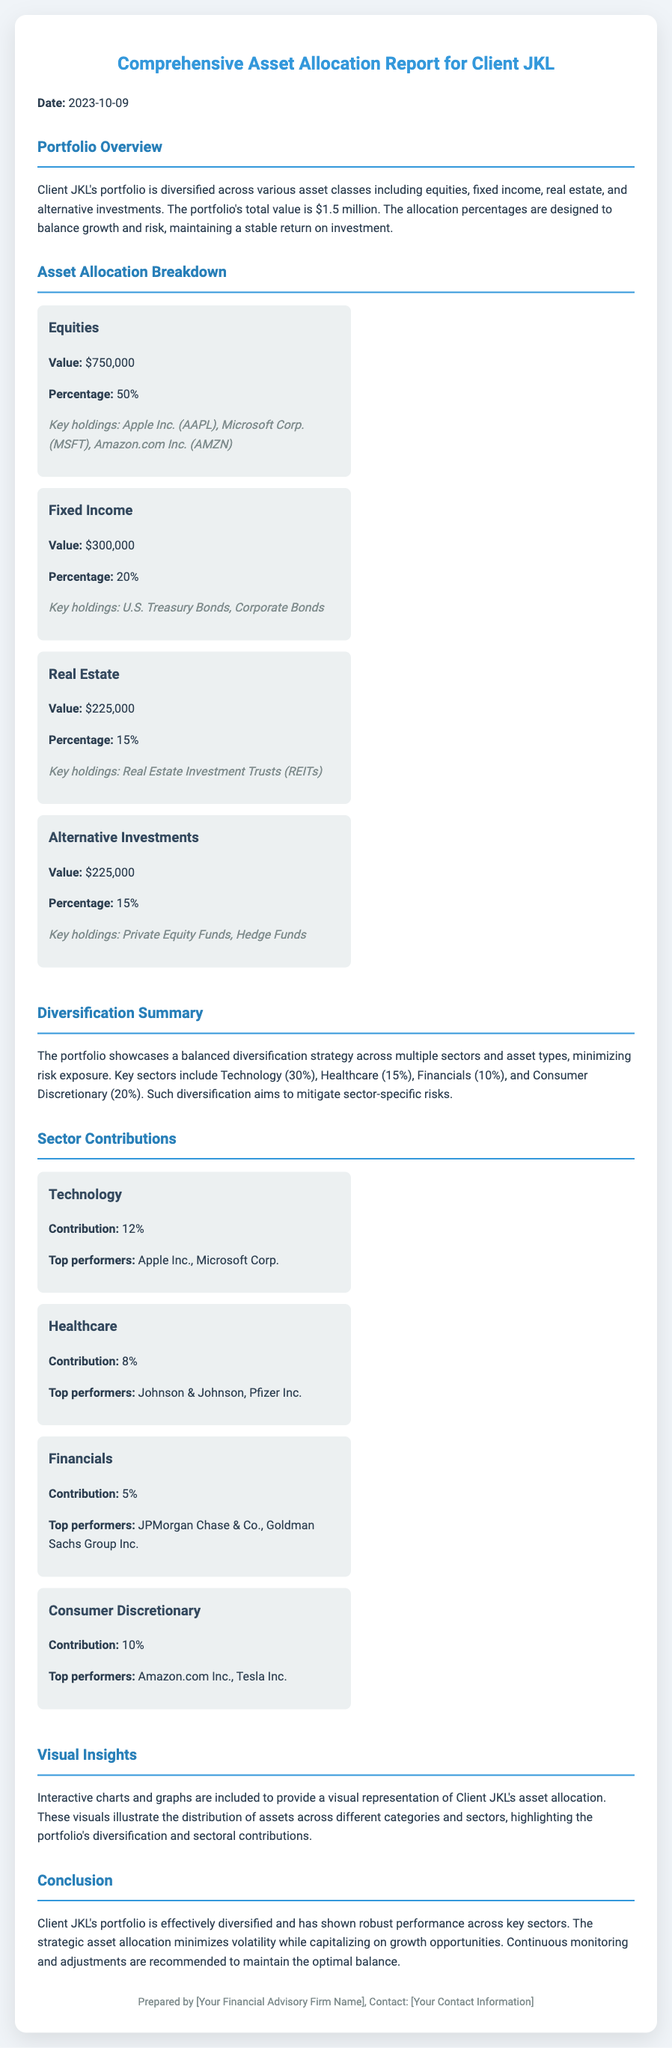What is the total value of Client JKL's portfolio? The total value is explicitly mentioned at the start of the Portfolio Overview section, which is $1.5 million.
Answer: $1.5 million What percentage of the portfolio is allocated to Equities? The percentage allocation for Equities is directly provided in the Asset Allocation Breakdown section.
Answer: 50% What are the key holdings in the Fixed Income category? The key holdings for Fixed Income are listed in the Asset Allocation Breakdown section as U.S. Treasury Bonds and Corporate Bonds.
Answer: U.S. Treasury Bonds, Corporate Bonds Which sector contributes 12% to the portfolio? The contribution percentage for each sector is clearly stated in the Sector Contributions section; Technology is noted as contributing 12%.
Answer: Technology What is the key strategy employed for Client JKL's portfolio? The key strategy is described in the Conclusion, emphasizing diversification and performance management.
Answer: Diversification How much of the portfolio is invested in Real Estate? The document specifies the value allocated to Real Estate in the Asset Allocation Breakdown section.
Answer: $225,000 Which investment type has the highest dollar value in the portfolio? The information is provided in the Asset Allocation Breakdown section, clearly identifying Equities as the highest.
Answer: Equities What are the top performers in the Consumer Discretionary sector? The top performers in Consumer Discretionary are listed in the Sector Contributions section.
Answer: Amazon.com Inc., Tesla Inc What type of interactive elements are mentioned in the Visual Insights section? The Visual Insights section refers to the presence of interactive charts and graphs.
Answer: Charts and graphs 